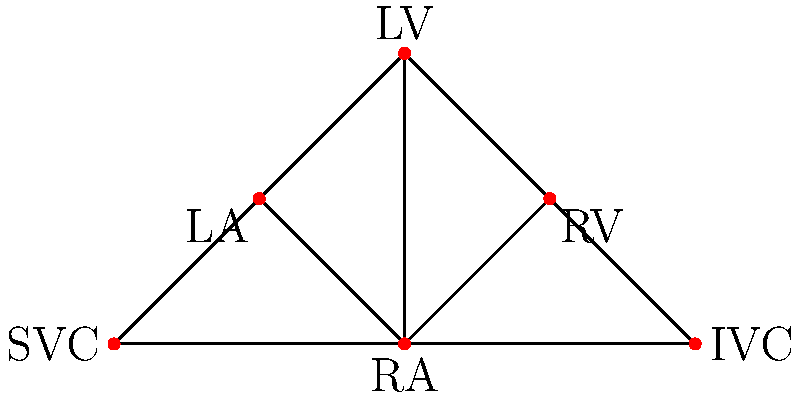In the network diagram representing different pacemaker electrode placements, which node has the highest degree centrality, and what does this imply about its importance in cardiac pacing? To answer this question, we need to follow these steps:

1. Understand degree centrality: In graph theory, degree centrality is a measure of the number of connections a node has to other nodes in the network.

2. Count the connections for each node:
   - RA (Right Atrium): 5 connections
   - RV (Right Ventricle): 3 connections
   - LA (Left Atrium): 3 connections
   - LV (Left Ventricle): 3 connections
   - SVC (Superior Vena Cava): 2 connections
   - IVC (Inferior Vena Cava): 2 connections

3. Identify the node with the highest degree centrality:
   The RA (Right Atrium) has the highest degree centrality with 5 connections.

4. Interpret the implications:
   The high degree centrality of the RA suggests that it has the most direct connections to other parts of the heart. In the context of cardiac pacing, this implies that:
   
   a) The RA is a central location for sensing cardiac activity.
   b) Placing a pacemaker electrode in the RA might provide better overall control and coordination of heart rhythm.
   c) The RA can potentially influence or pace multiple chambers of the heart more effectively.
   d) It may be an ideal location for single-lead pacing systems that aim to coordinate both atrial and ventricular activity.

5. Consider clinical relevance:
   While the RA shows high centrality in this network, it's important to note that optimal pacemaker placement depends on various clinical factors, including the specific type of arrhythmia, cardiac anatomy, and individual patient needs.
Answer: RA (Right Atrium); central for sensing and pacing multiple chambers. 